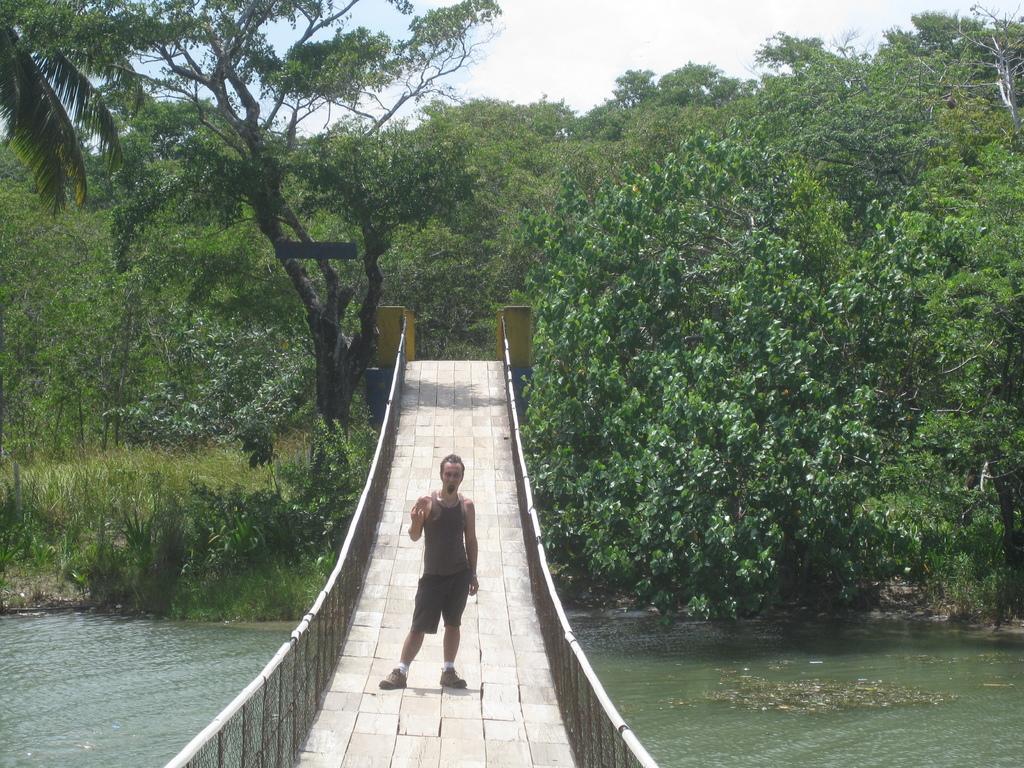Can you describe this image briefly? This image consists of a man standing on the bridge. At the bottom, there is water. In the background, there are many trees. It looks like it is clicked near the forest. 